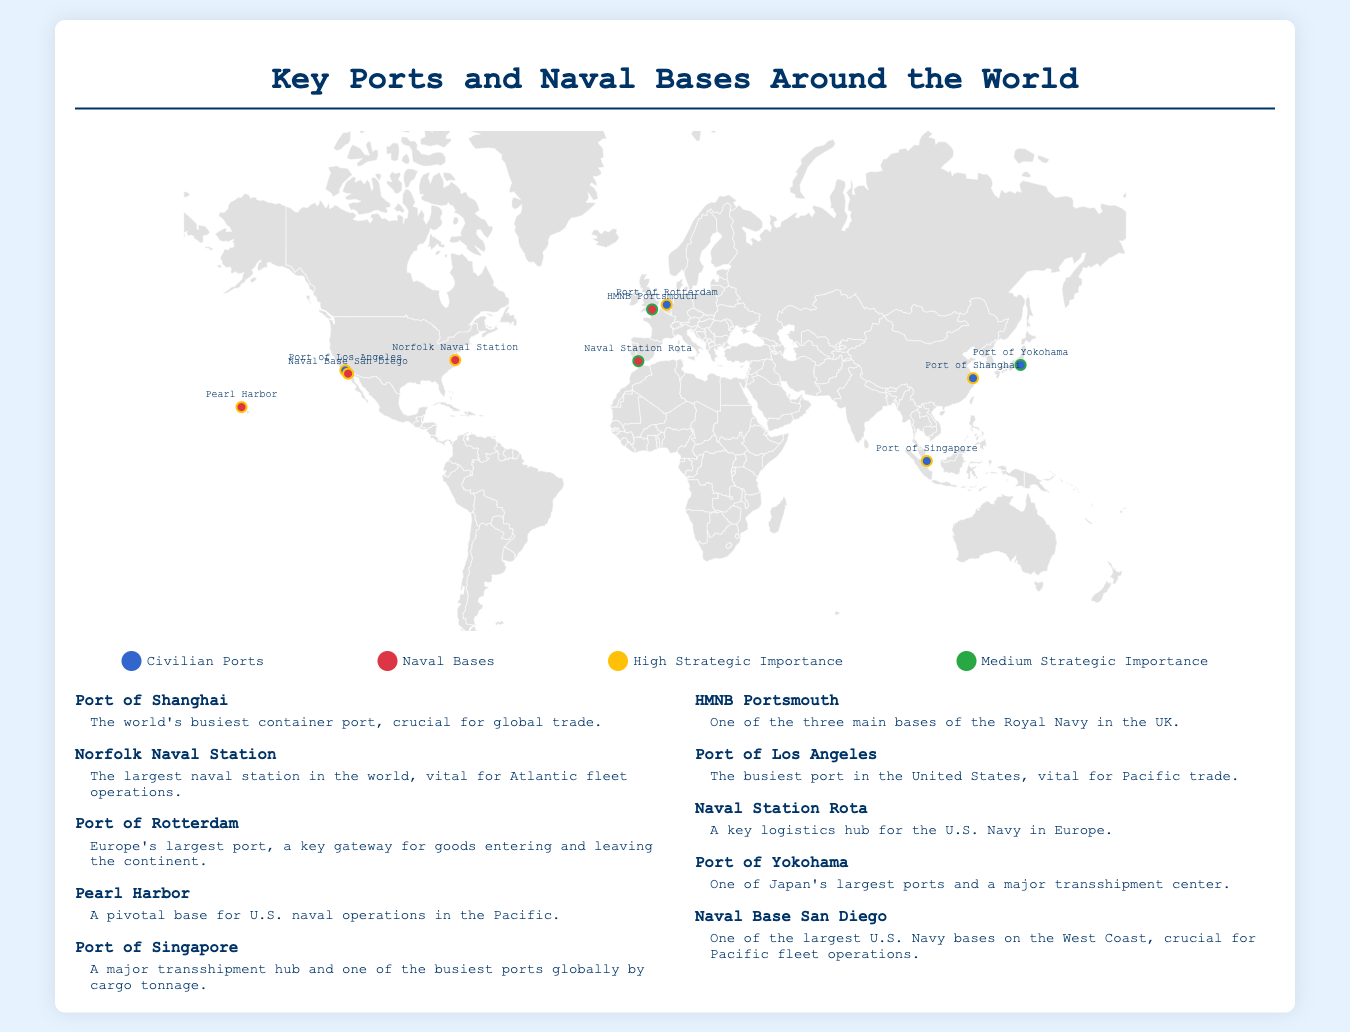What is the world's busiest container port? The document lists the Port of Shanghai as the world's busiest container port, which is crucial for global trade.
Answer: Port of Shanghai What type of location is Norfolk Naval Station? The infographic indicates Norfolk Naval Station as a naval base, which is vital for Atlantic fleet operations.
Answer: Naval base Which port is Europe's largest? The document points out the Port of Rotterdam as Europe's largest port, acting as a key gateway for goods entering and leaving the continent.
Answer: Port of Rotterdam What is the strategic importance of US Naval Base San Diego? The infographic labels Naval Base San Diego as high strategic importance, crucial for Pacific fleet operations.
Answer: High How many major ports are mentioned in the infographic? The document lists a total of 10 major ports and naval bases.
Answer: 10 What color represents civilian ports in the legend? The legend of the infographic uses the color blue (#3366cc) to indicate civilian ports.
Answer: Blue Which port served as a pivotal base for U.S. naval operations in the Pacific? According to the document, Pearl Harbor is described as a pivotal base for U.S. naval operations in the Pacific.
Answer: Pearl Harbor What are the distinct classifications for the strategic importance of the locations? The infographic distinguishes locations based on their strategic importance into high and medium categories.
Answer: High and Medium Which port is identified as a major transshipment hub? The document identifies the Port of Singapore as a major transshipment hub and one of the busiest ports globally by cargo tonnage.
Answer: Port of Singapore 